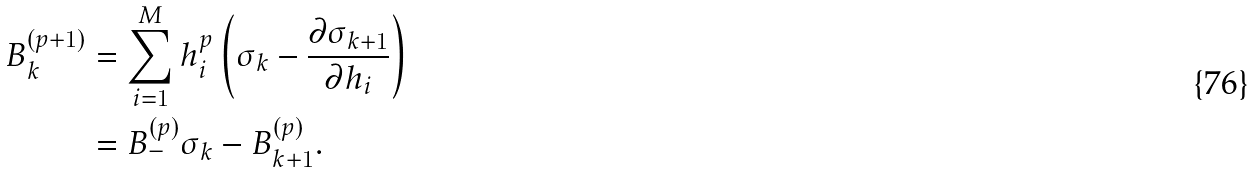Convert formula to latex. <formula><loc_0><loc_0><loc_500><loc_500>B _ { k } ^ { ( p + 1 ) } & = \sum _ { i = 1 } ^ { M } h _ { i } ^ { p } \left ( \sigma _ { k } - \frac { \partial \sigma _ { k + 1 } } { \partial h _ { i } } \right ) \\ & = B _ { - } ^ { ( p ) } \sigma _ { k } - B _ { k + 1 } ^ { ( p ) } .</formula> 